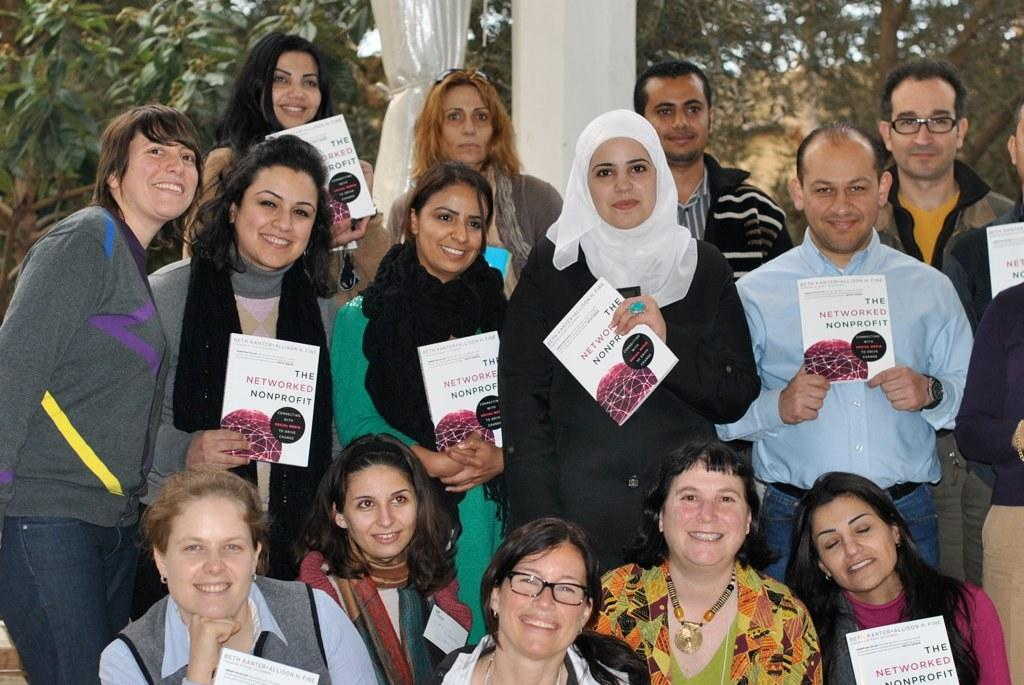What are the people in the image doing? The people in the image are holding books. What can be seen in the background of the image? There is a curtain, a pillar, trees, and the sky visible in the background of the image. How many babies are present in the image? There are no babies present in the image; it features a group of people holding books. What type of error can be seen in the image? There is no error present in the image; it is a clear and accurate representation of the group of people holding books and the background elements. 